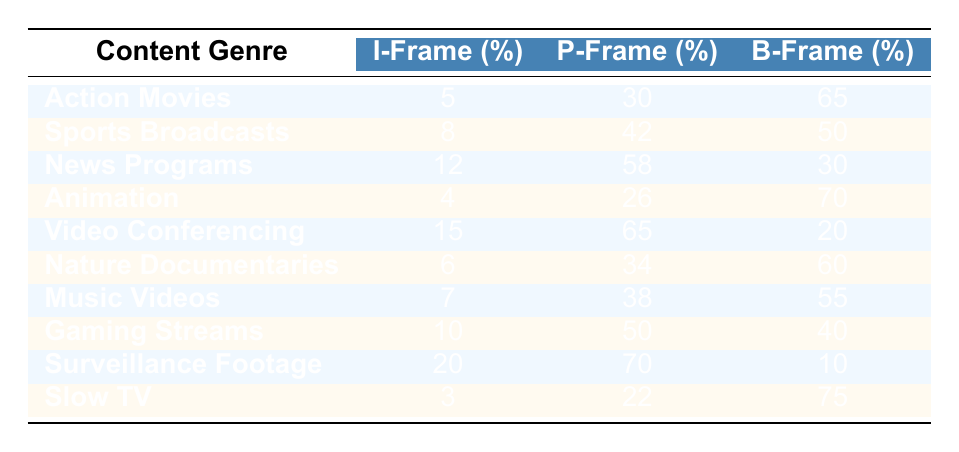What is the percentage of I-Frames in Action Movies? The table indicates that Action Movies have 5% I-Frames.
Answer: 5% Which content genre has the highest percentage of B-Frames? By examining the table, Surveillance Footage has the highest percentage of B-Frames at 70%.
Answer: 70% What is the average percentage of P-Frames across all genres? To calculate the average, sum the P-Frame percentages: (30 + 42 + 58 + 26 + 65 + 34 + 38 + 50 + 70 + 22) =  405, and divide by the number of genres (10), which gives 405/10 = 40.5.
Answer: 40.5% Is the percentage of I-Frames in Sports Broadcasts greater than 10%? The table shows that Sports Broadcasts have 8% I-Frames, which is less than 10%.
Answer: No Which genres have more B-Frames than P-Frames? Focusing on the data, we can see that Action Movies (65% B-Frames and 30% P-Frames), Animation (70% B-Frames and 26% P-Frames), and Slow TV (75% B-Frames and 22% P-Frames) have more B-Frames than P-Frames.
Answer: Action Movies, Animation, Slow TV 